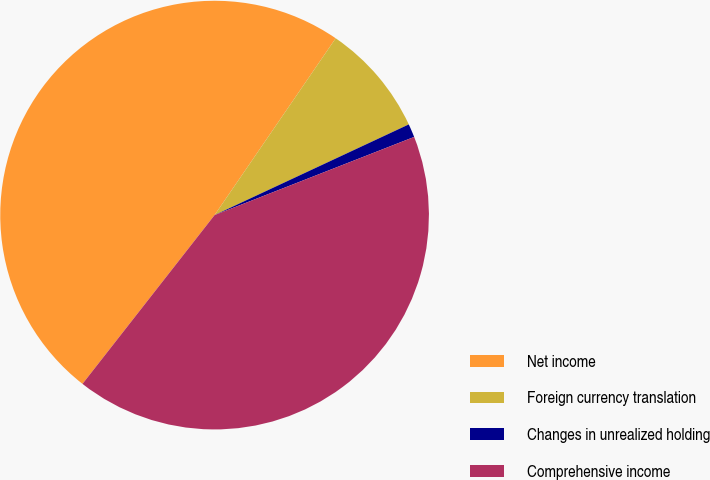Convert chart to OTSL. <chart><loc_0><loc_0><loc_500><loc_500><pie_chart><fcel>Net income<fcel>Foreign currency translation<fcel>Changes in unrealized holding<fcel>Comprehensive income<nl><fcel>48.99%<fcel>8.49%<fcel>1.01%<fcel>41.51%<nl></chart> 